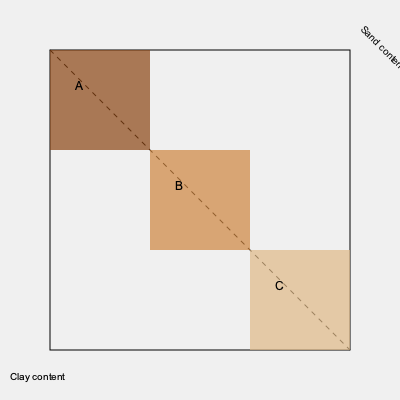Based on the color-coded soil composition map of your farmland, what can be inferred about the clay-to-sand ratio gradient from section A to section C, and how might this affect crop selection and management practices? To answer this question, we need to analyze the color gradient and its implications:

1. Color interpretation:
   - Section A (top-left): Darkest brown, indicating highest clay content
   - Section B (middle): Medium brown, suggesting a mix of clay and sand
   - Section C (bottom-right): Lightest brown, implying highest sand content

2. Clay-to-sand ratio gradient:
   - The diagonal line from A to C represents a gradual transition from clay-rich to sand-rich soil.
   - The clay-to-sand ratio decreases from A to C.

3. Soil properties affected by clay-to-sand ratio:
   - Water retention: Clay retains more water than sand
   - Nutrient holding capacity: Clay holds more nutrients than sand
   - Drainage: Sandy soil drains faster than clay soil
   - Aeration: Sandy soil has better aeration than clay soil

4. Implications for crop selection:
   - Section A: Suitable for crops that prefer moisture-retentive, nutrient-rich soils (e.g., rice, wheat)
   - Section B: Versatile for a wide range of crops due to balanced composition
   - Section C: Ideal for drought-tolerant crops or those requiring well-drained soil (e.g., carrots, potatoes)

5. Management practices:
   - Section A: May require improved drainage and careful irrigation to prevent waterlogging
   - Section B: Balanced approach to irrigation and fertilization
   - Section C: More frequent irrigation and fertilization may be necessary due to faster drainage and lower nutrient retention

The clay-to-sand ratio gradient from A to C implies a transition from water-retentive, nutrient-rich soil to well-drained, potentially nutrient-poor soil, necessitating adapted crop selection and management practices across the farmland.
Answer: Decreasing clay-to-sand ratio from A to C, requiring adapted crop selection and management practices for optimal soil utilization. 